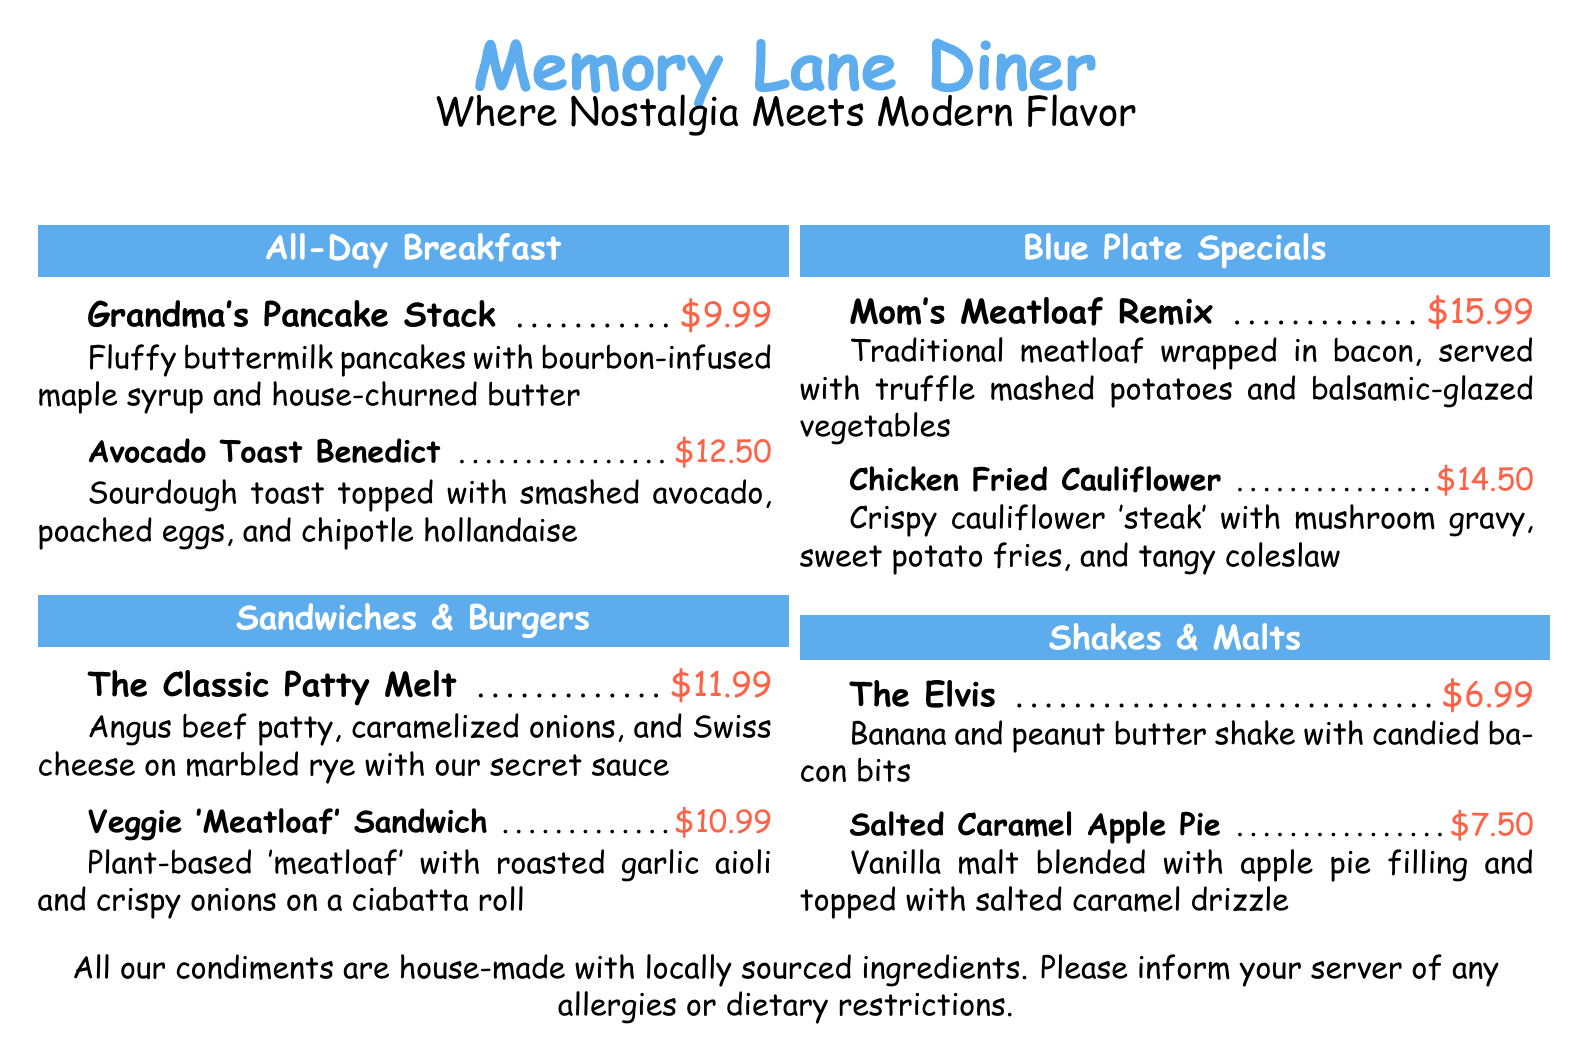what is the price of Grandma's Pancake Stack? The price of Grandma's Pancake Stack is listed next to the dish in the menu.
Answer: $9.99 what is the house-made condiment policy? The condiment policy states that all condiments are house-made with locally sourced ingredients.
Answer: house-made with locally sourced ingredients what is featured in The Elvis shake? The Elvis shake features banana and peanut butter with an additional topping.
Answer: banana and peanut butter shake with candied bacon bits how much does the Chicken Fried Cauliflower cost? The cost of Chicken Fried Cauliflower is indicated in the menu section for Blue Plate Specials.
Answer: $14.50 which sandwich includes Swiss cheese? The sandwich containing Swiss cheese is mentioned in the Sandwiches & Burgers section of the menu.
Answer: The Classic Patty Melt what is unique about the Veggie 'Meatloaf' Sandwich? The Veggie 'Meatloaf' Sandwich is unique because it is plant-based and comes with a specific condiment.
Answer: Plant-based 'meatloaf' with roasted garlic aioli how many breakfast items are listed? The number of breakfast items can be counted from the All-Day Breakfast section, where specific items are mentioned.
Answer: 2 which dish is wrapped in bacon? The dish that is wrapped in bacon is indicated under the Blue Plate Specials as a specific comfort food.
Answer: Mom's Meatloaf Remix what type of bread is used for the Veggie 'Meatloaf' Sandwich? The type of bread used is mentioned in the description of the Veggie 'Meatloaf' Sandwich in the menu.
Answer: ciabatta roll 